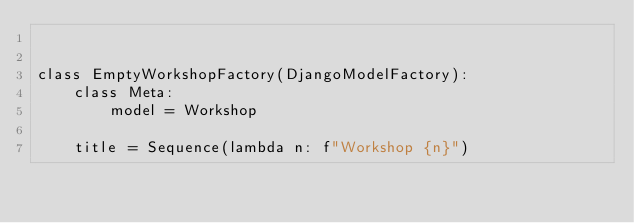Convert code to text. <code><loc_0><loc_0><loc_500><loc_500><_Python_>

class EmptyWorkshopFactory(DjangoModelFactory):
    class Meta:
        model = Workshop

    title = Sequence(lambda n: f"Workshop {n}")
</code> 